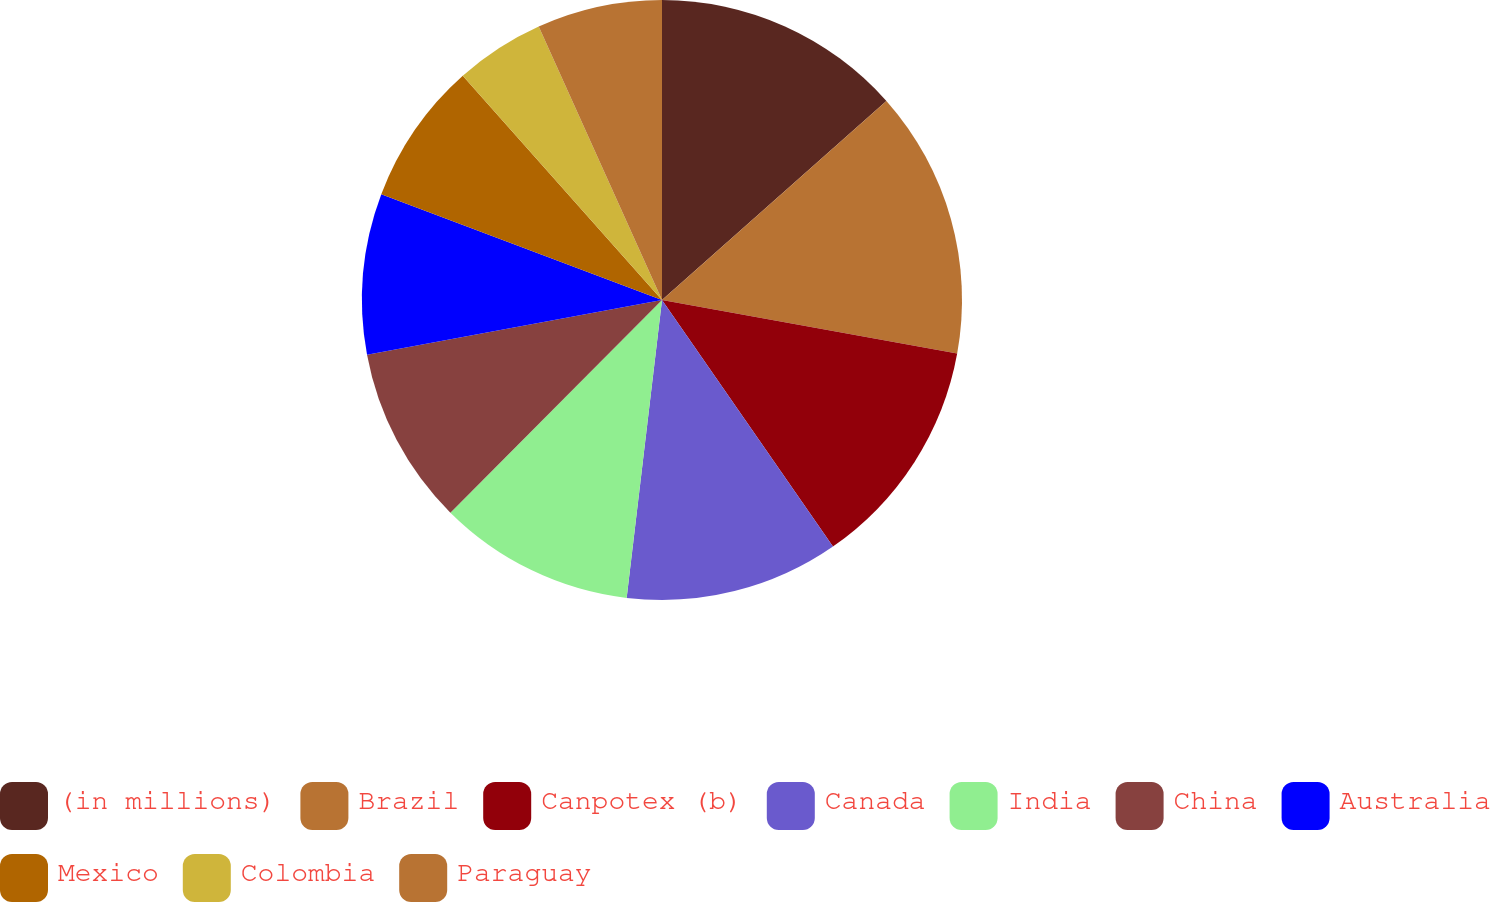Convert chart. <chart><loc_0><loc_0><loc_500><loc_500><pie_chart><fcel>(in millions)<fcel>Brazil<fcel>Canpotex (b)<fcel>Canada<fcel>India<fcel>China<fcel>Australia<fcel>Mexico<fcel>Colombia<fcel>Paraguay<nl><fcel>13.45%<fcel>14.41%<fcel>12.49%<fcel>11.53%<fcel>10.58%<fcel>9.62%<fcel>8.66%<fcel>7.7%<fcel>4.82%<fcel>6.74%<nl></chart> 